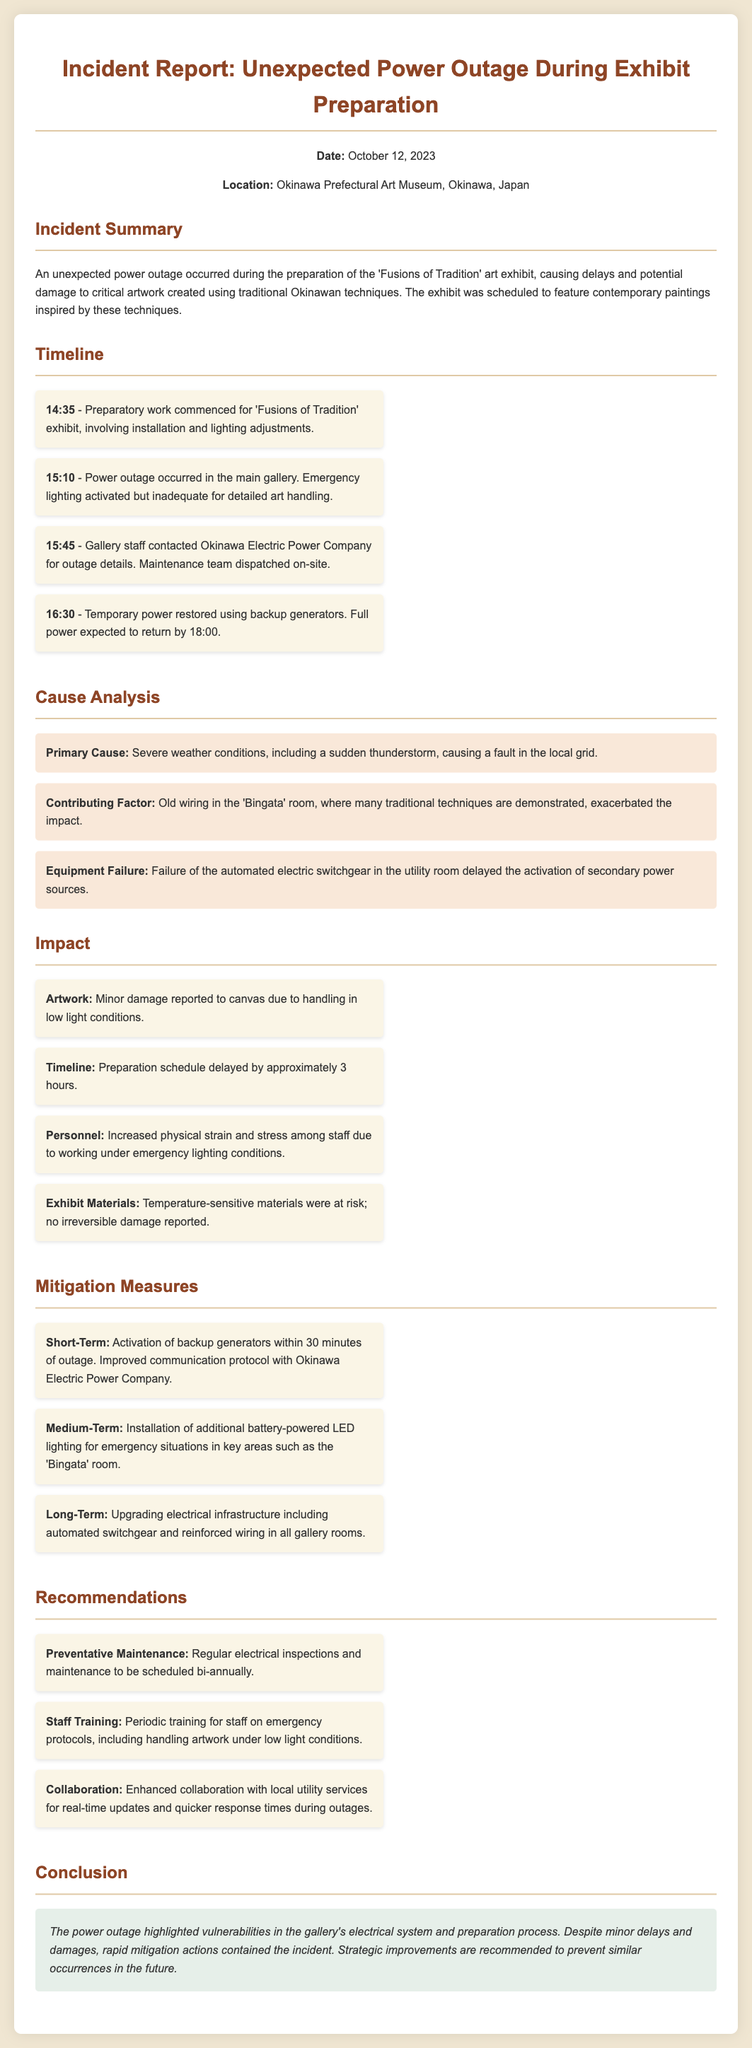What was the date of the incident? The date of the incident is stated in the document, which is October 12, 2023.
Answer: October 12, 2023 Where did the power outage occur? The location of the power outage is specified in the document as the Okinawa Prefectural Art Museum, Okinawa, Japan.
Answer: Okinawa Prefectural Art Museum, Okinawa, Japan What was the primary cause of the power outage? The primary cause is detailed as severe weather conditions, including a sudden thunderstorm.
Answer: Severe weather conditions How long was the preparation schedule delayed? The document mentions that the preparation schedule was delayed by approximately 3 hours.
Answer: Approximately 3 hours What emergency measure was taken shortly after the outage started? The document notes that backup generators were activated within 30 minutes of the outage.
Answer: Activation of backup generators Which room's old wiring was a contributing factor? The contributing factor highlighted in the document is the old wiring in the 'Bingata' room.
Answer: 'Bingata' room What type of training is recommended for staff? The document recommends periodic training for staff on emergency protocols.
Answer: Periodic training on emergency protocols What is one of the medium-term mitigation measures? The medium-term measure includes the installation of additional battery-powered LED lighting for emergency situations.
Answer: Installation of additional battery-powered LED lighting What is the conclusion of the incident report? The conclusion emphasizes the need for strategic improvements to prevent similar occurrences in the future.
Answer: Strategic improvements are recommended to prevent similar occurrences 